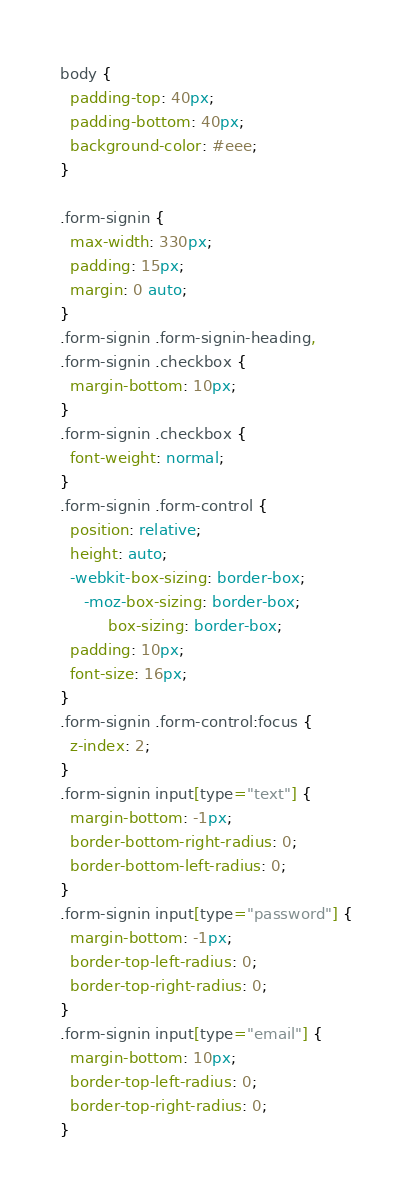<code> <loc_0><loc_0><loc_500><loc_500><_CSS_>body {
  padding-top: 40px;
  padding-bottom: 40px;
  background-color: #eee;
}

.form-signin {
  max-width: 330px;
  padding: 15px;
  margin: 0 auto;
}
.form-signin .form-signin-heading,
.form-signin .checkbox {
  margin-bottom: 10px;
}
.form-signin .checkbox {
  font-weight: normal;
}
.form-signin .form-control {
  position: relative;
  height: auto;
  -webkit-box-sizing: border-box;
     -moz-box-sizing: border-box;
          box-sizing: border-box;
  padding: 10px;
  font-size: 16px;
}
.form-signin .form-control:focus {
  z-index: 2;
}
.form-signin input[type="text"] {
  margin-bottom: -1px;
  border-bottom-right-radius: 0;
  border-bottom-left-radius: 0;
}
.form-signin input[type="password"] {
  margin-bottom: -1px;
  border-top-left-radius: 0;
  border-top-right-radius: 0;
}
.form-signin input[type="email"] {
  margin-bottom: 10px;
  border-top-left-radius: 0;
  border-top-right-radius: 0;
}
</code> 